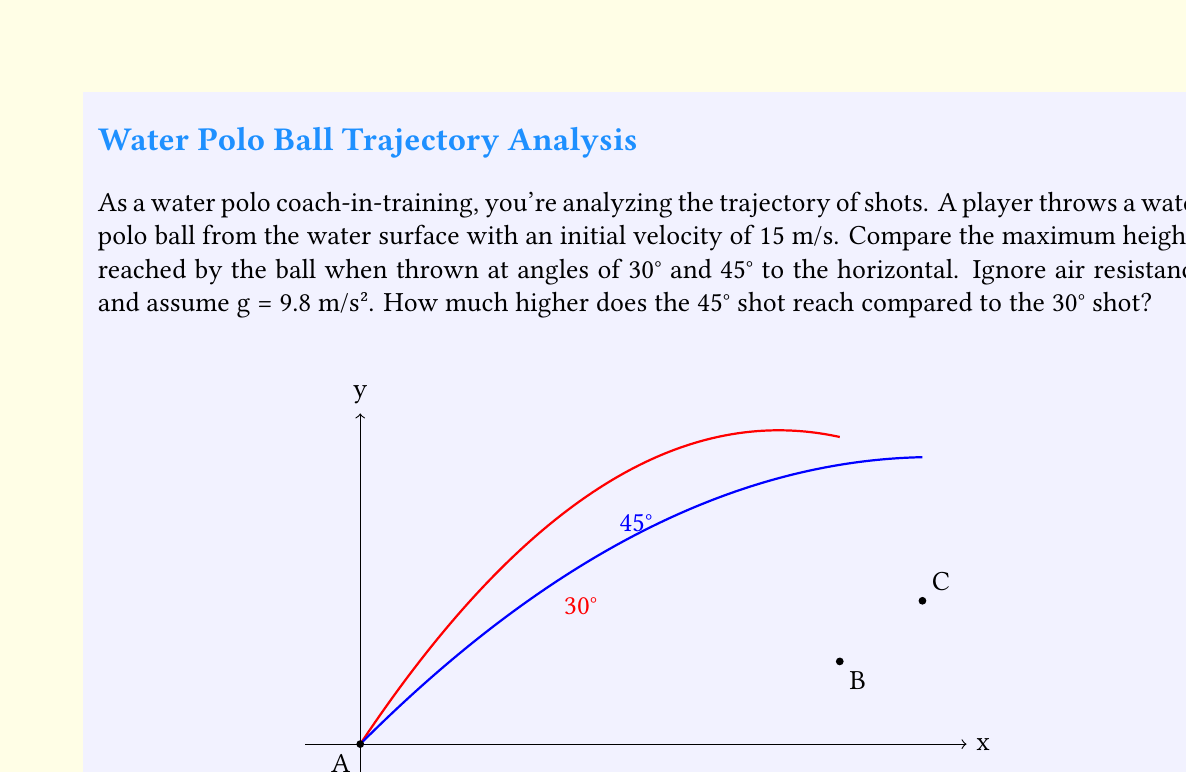Solve this math problem. Let's approach this step-by-step:

1) The maximum height of a projectile is given by the formula:

   $$h_{max} = \frac{v_0^2 \sin^2 \theta}{2g}$$

   where $v_0$ is the initial velocity, $\theta$ is the angle of launch, and $g$ is the acceleration due to gravity.

2) For the 30° angle:
   $$h_{max30} = \frac{(15 \text{ m/s})^2 \sin^2 30°}{2(9.8 \text{ m/s}^2)}$$
   $$= \frac{225 \text{ m}^2 \cdot 0.25}{19.6 \text{ m/s}^2}$$
   $$= 2.87 \text{ m}$$

3) For the 45° angle:
   $$h_{max45} = \frac{(15 \text{ m/s})^2 \sin^2 45°}{2(9.8 \text{ m/s}^2)}$$
   $$= \frac{225 \text{ m}^2 \cdot 0.5}{19.6 \text{ m/s}^2}$$
   $$= 5.74 \text{ m}$$

4) The difference in height is:
   $$\Delta h = h_{max45} - h_{max30} = 5.74 \text{ m} - 2.87 \text{ m} = 2.87 \text{ m}$$

Therefore, the 45° shot reaches 2.87 m higher than the 30° shot.
Answer: 2.87 m 